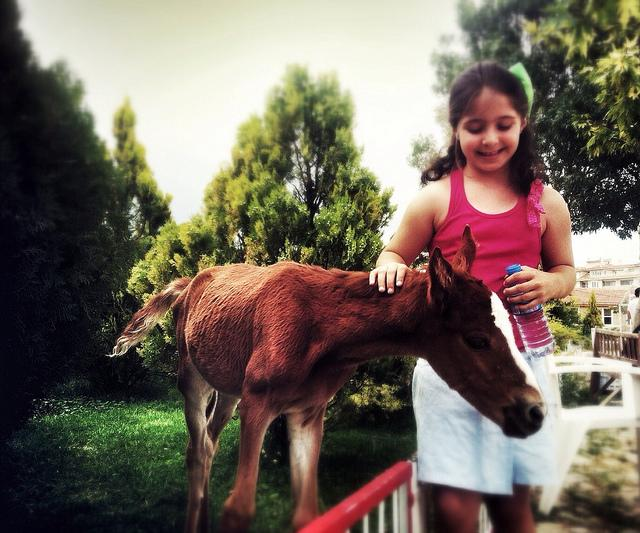What color is the cap on top of the water bottle held by the child?

Choices:
A) white
B) black
C) blue
D) green blue 